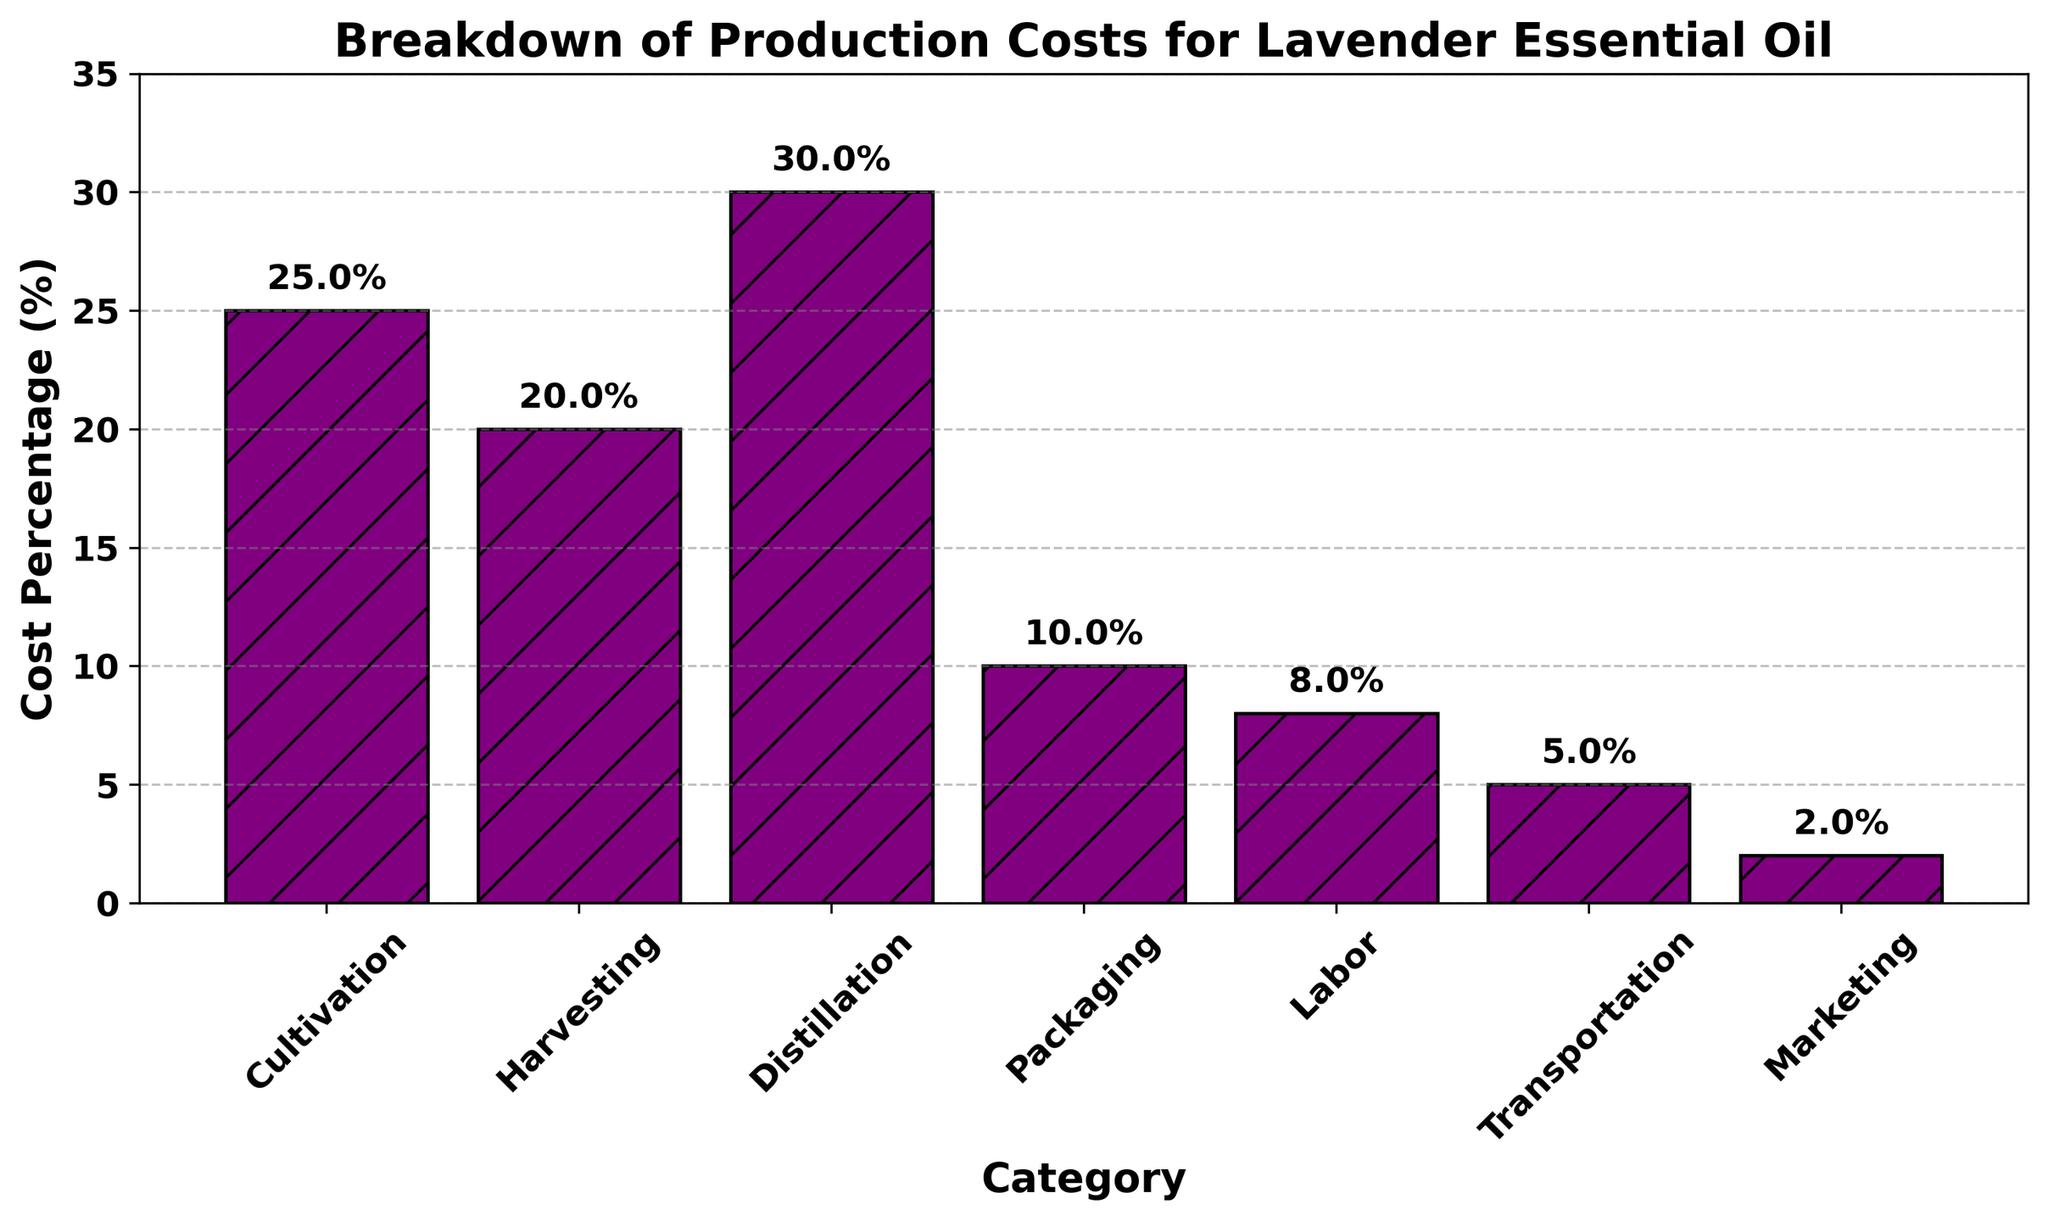What category has the highest production cost percentage? The highest bar in the chart represents the category with the highest production cost. According to the figure, the 'Distillation' bar is the tallest.
Answer: Distillation What's the total percentage of costs from Cultivation and Harvesting? Adding the cost percentages for 'Cultivation' (25%) and 'Harvesting' (20%) gives us the total percentage for these two categories: 25% + 20% = 45%.
Answer: 45% How does the cost percentage of Transportation compare to Marketing? According to the chart, the 'Transportation' cost is 5%, and the 'Marketing' cost is 2%. Since 5% is greater than 2%, Transportation costs more.
Answer: Transportation costs more Which cost category has the smallest contribution to the total production costs? The smallest bar in the figure represents the category with the smallest cost percentage. The 'Marketing' bar is the shortest, indicating it has the smallest contribution.
Answer: Marketing If you combine the costs of Labor and Packaging, how do they compare to Distillation in terms of percentage? The cost of 'Labor' is 8%, and 'Packaging' is 10%. Combined, they add up to 18%. The 'Distillation' cost is 30%. Thus, 18% is less than 30%.
Answer: Combined cost is less What percentage of the total cost does the combination of Marketing and Transportation represent? Adding the cost percentages for 'Marketing' (2%) and 'Transportation' (5%) gives us the total percentage for these two categories: 2% + 5% = 7%.
Answer: 7% Which two categories together make up exactly half the total production costs? Searching for two categories whose sum equals 50%, we find 'Cultivation' (25%) and 'Distillation' (30%) together exceed half the production cost, but 'Harvesting' (20%) and 'Distillation' (30%) together equal 50%.
Answer: Harvesting and Distillation If distillation costs were reduced by 10%, what would the new percentage be for distillation? Reducing the 'Distillation' cost by 10% from its current 30%: 30% - 10% = 20%.
Answer: 20% What is the cost percentage difference between the highest and lowest cost categories? The highest cost ('Distillation') is 30%, and the lowest cost ('Marketing') is 2%. The difference is 30% - 2% = 28%.
Answer: 28% Is the cost percentage for Labor closer to that of Packaging or that of Transportation? 'Labor' is 8%, 'Packaging' is 10%, and 'Transportation' is 5%. The difference between Labor and Packaging is 2% (10% - 8%), and the difference between Labor and Transportation is 3% (8% - 5%). Therefore, Labor is closer to Packaging.
Answer: Labor is closer to Packaging 